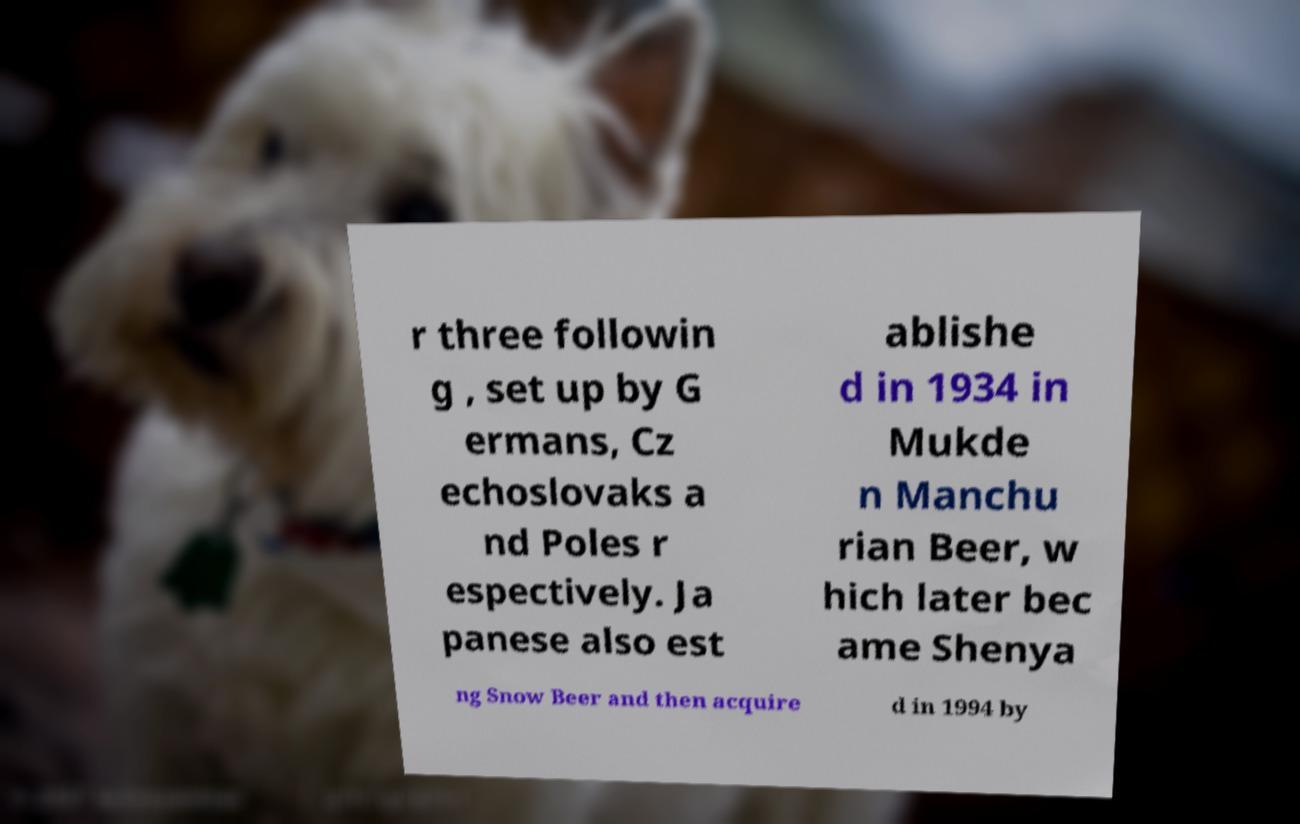Please read and relay the text visible in this image. What does it say? r three followin g , set up by G ermans, Cz echoslovaks a nd Poles r espectively. Ja panese also est ablishe d in 1934 in Mukde n Manchu rian Beer, w hich later bec ame Shenya ng Snow Beer and then acquire d in 1994 by 